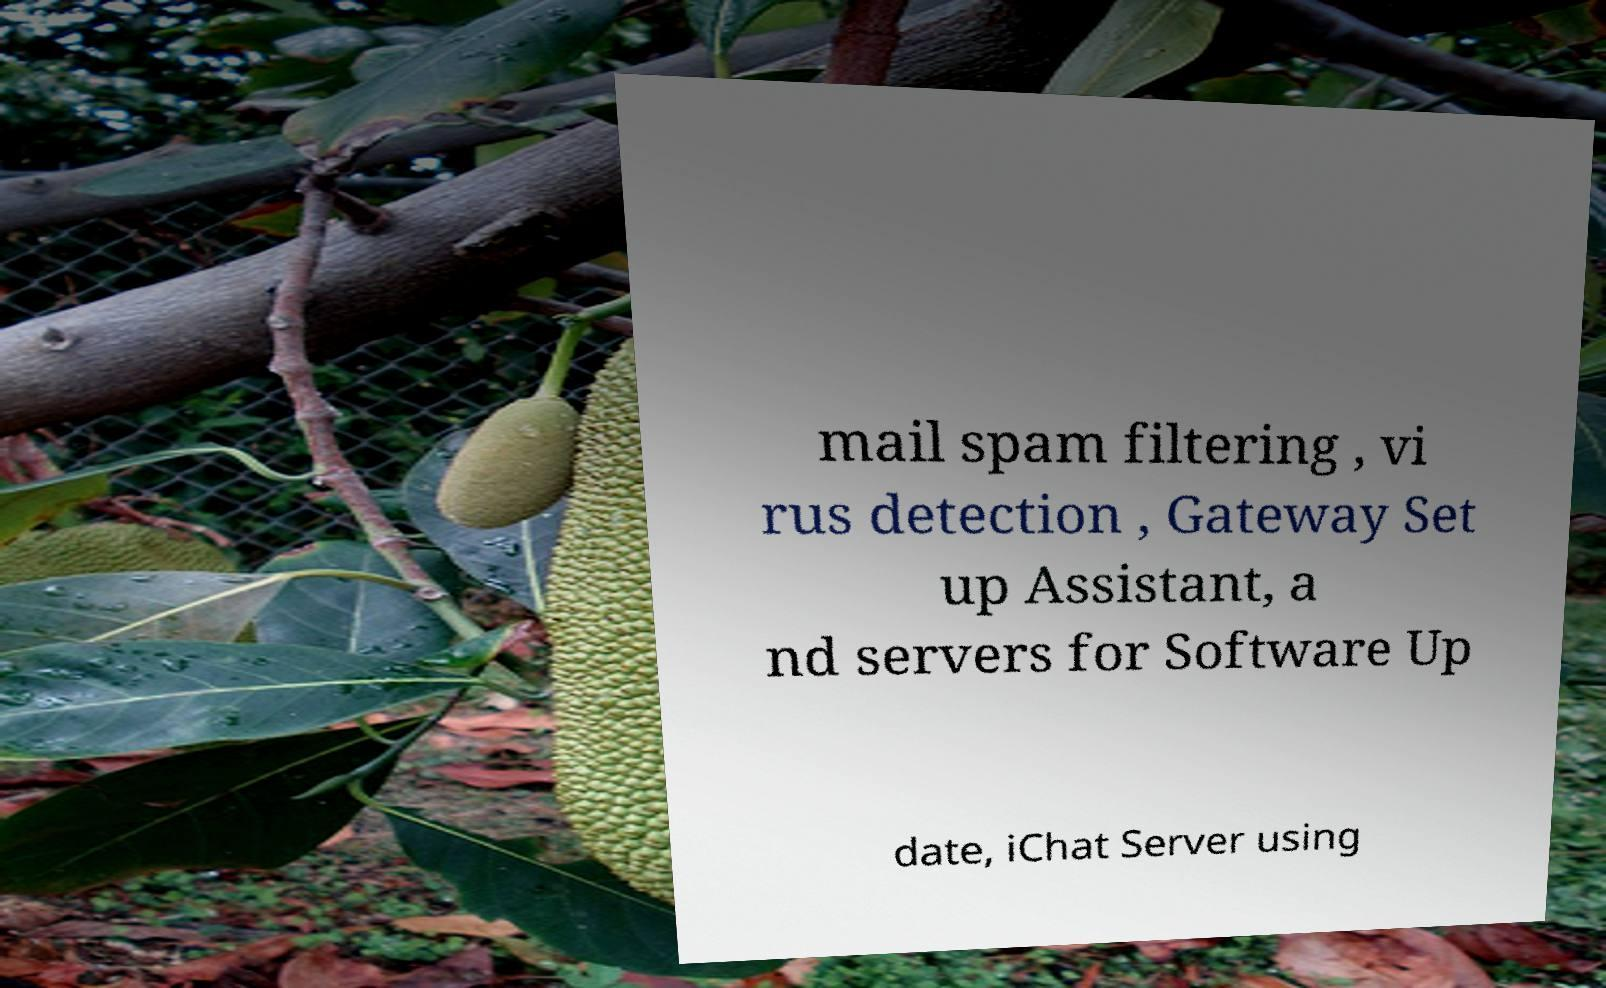Please identify and transcribe the text found in this image. mail spam filtering , vi rus detection , Gateway Set up Assistant, a nd servers for Software Up date, iChat Server using 